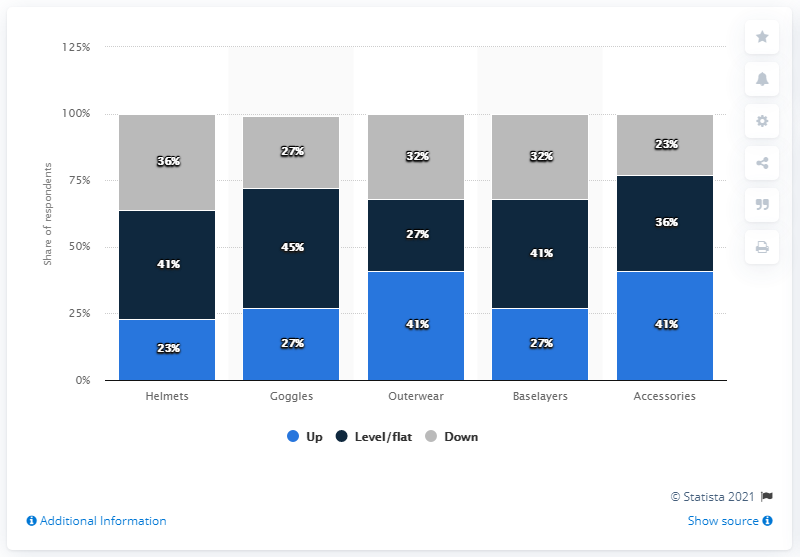Specify some key components in this picture. The sales performance of accessories by Level/flat is 36%. According to a survey of retailers, 41% reported that their outerwear sales increased in October and November of 2016. The ratio between the upper category of Goggles and Baselayers is 1:1. Accessories performed the best among all categories, as it received the highest average satisfaction score. 